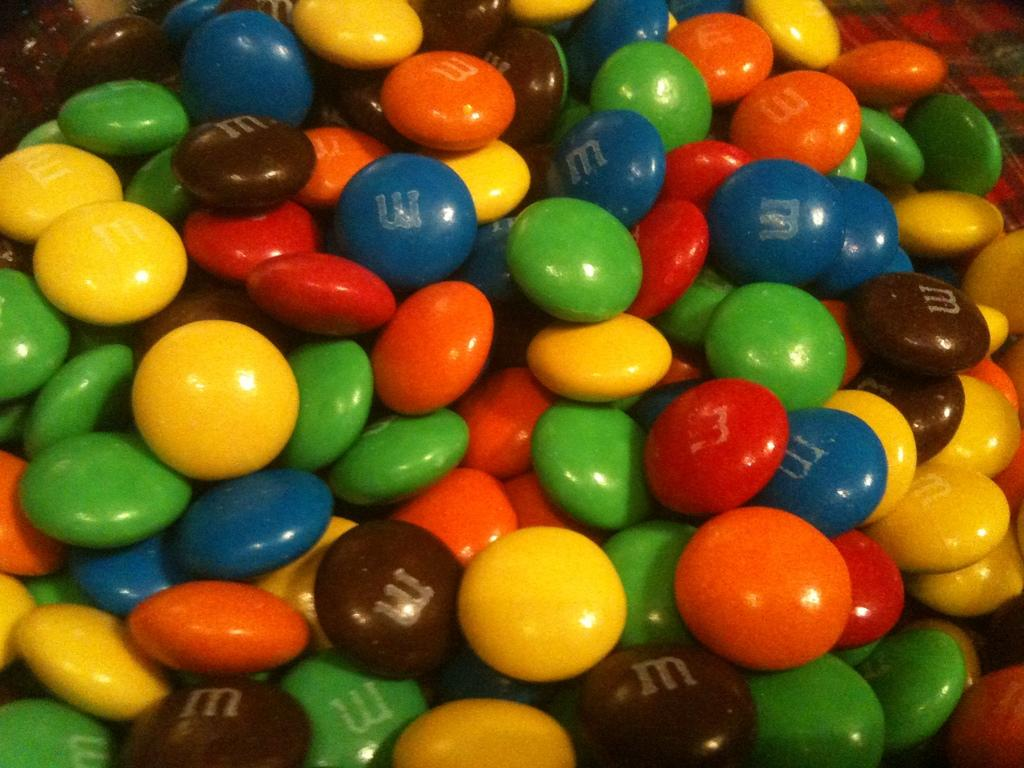What types of objects can be seen in the image? There are gems and chocolates in the image. What is the surface on which the gems and chocolates are placed? The gems and chocolates are on cement. How many fish can be seen swimming in the image? There are no fish present in the image; it features gems and chocolates on cement. Is there a bridge visible in the image? There is no bridge present in the image. 